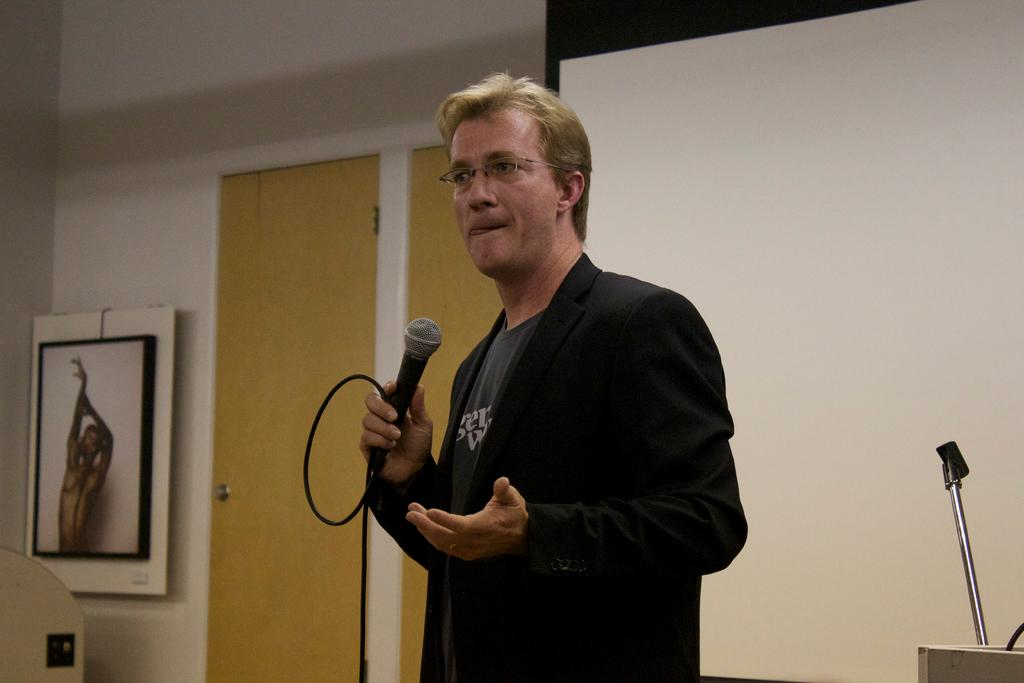What is the main subject of the image? The main subject of the image is a man. What is the man doing in the image? The man is standing and speaking with the help of a microphone. What object is near the man in the image? There is a podium on the side of the man. What is located behind the man in the image? There is a projector screen behind the man. Can you describe any other objects in the image? There is a photo frame on the wall in the image. How many houses are visible in the image? There are no houses visible in the image. Are there any women or children present in the image? There is no mention of women or children in the image; it primarily features a man speaking with a microphone and other related objects. 